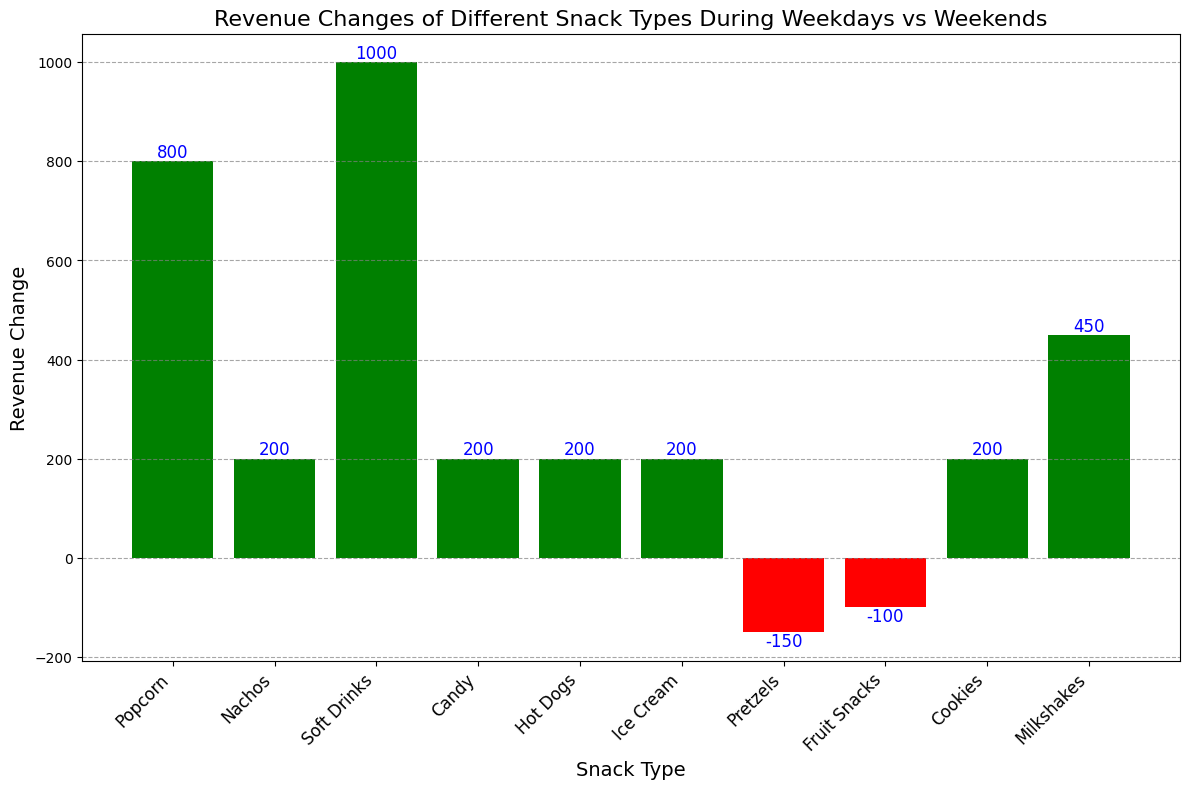Which snack type had the largest increase in revenue from weekdays to weekends? By observing the height of the bars, the tallest green bar represents Soft Drinks with a revenue change of 1000.
Answer: Soft Drinks Which snack types showed a decrease in revenue from weekdays to weekends? By looking at the red bars, Pretzels and Fruit Snacks showed a decrease in revenue.
Answer: Pretzels, Fruit Snacks What is the total revenue change for snacks that saw an increase? Sum the positive revenue changes for all green bars: 800 (Popcorn) + 200 (Nachos) + 1000 (Soft Drinks) + 200 (Candy) + 200 (Hot Dogs) + 200 (Ice Cream) + 200 (Cookies) + 450 (Milkshakes). Total: 800 + 200 + 1000 + 200 + 200 + 200 + 200 + 450 = 3250.
Answer: 3250 What is the total revenue change for snacks that saw a decrease? Sum the negative revenue changes for all red bars: -150 (Pretzels) + -100 (Fruit Snacks). Total: -150 + -100 = -250.
Answer: -250 What is the difference in revenue change between the snack type with the highest increase and the one with the highest decrease? The highest increase is 1000 (Soft Drinks) and the highest decrease is -150 (Pretzels). Difference: 1000 - (-150) = 1000 + 150 = 1150.
Answer: 1150 Which snack type had the smallest increase in revenue from weekdays to weekends? From the green bars, the smallest increase is for multiple snack types: Nachos, Candy, Hot Dogs, Ice Cream, Cookies all with a revenue change of 200.
Answer: Nachos, Candy, Hot Dogs, Ice Cream, Cookies Compare the revenue changes of Popcorn and Milkshakes; which one had a higher increase? Popcorn has a revenue change of 800, while Milkshakes have 450. Since 800 is greater than 450, Popcorn had a higher increase.
Answer: Popcorn What is the average revenue change for all snack types? Sum all revenue changes and divide by the number of snack types: Total = 800 (Popcorn) + 200 (Nachos) + 1000 (Soft Drinks) + 200 (Candy) + 200 (Hot Dogs) + 200 (Ice Cream) + (-150) (Pretzels) + (-100) (Fruit Snacks) + 200 (Cookies) + 450 (Milkshakes). Sum: 1000 + 1000 + 800 - 250 = 3750. Average: 3750 / 10 = 375.
Answer: 375 What can be inferred about snack types with a negative revenue change visually? The red bars indicate a decrease in revenue change, implying that Pretzels and Fruit Snacks were less popular on weekends compared to weekdays.
Answer: Less popular on weekends 